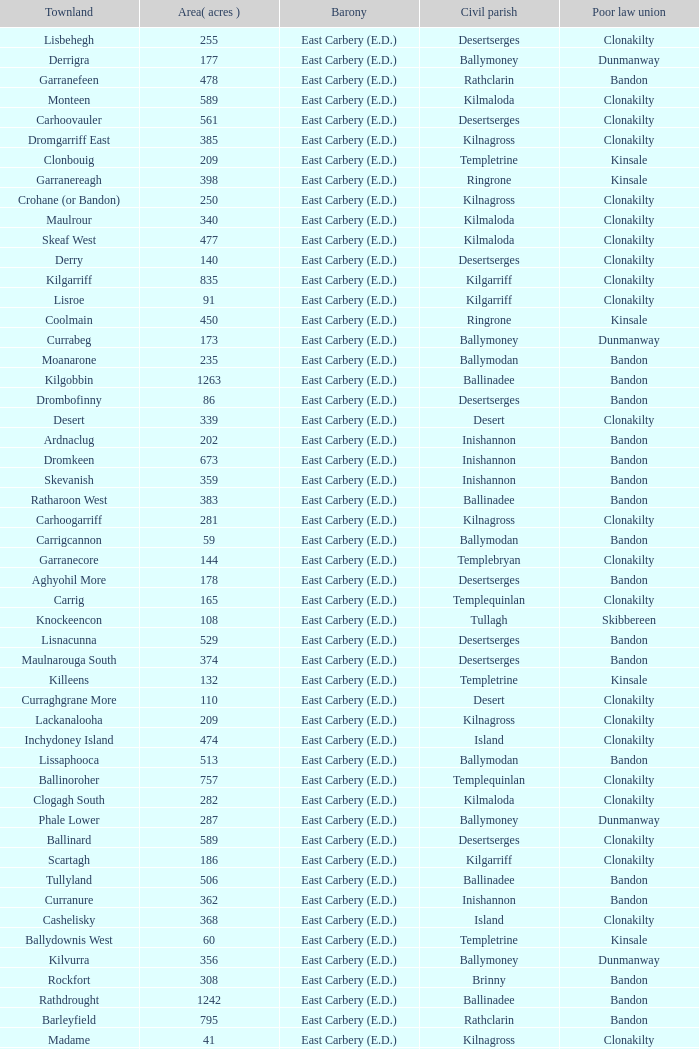What is the poor law union of the Ardacrow townland? Bandon. 